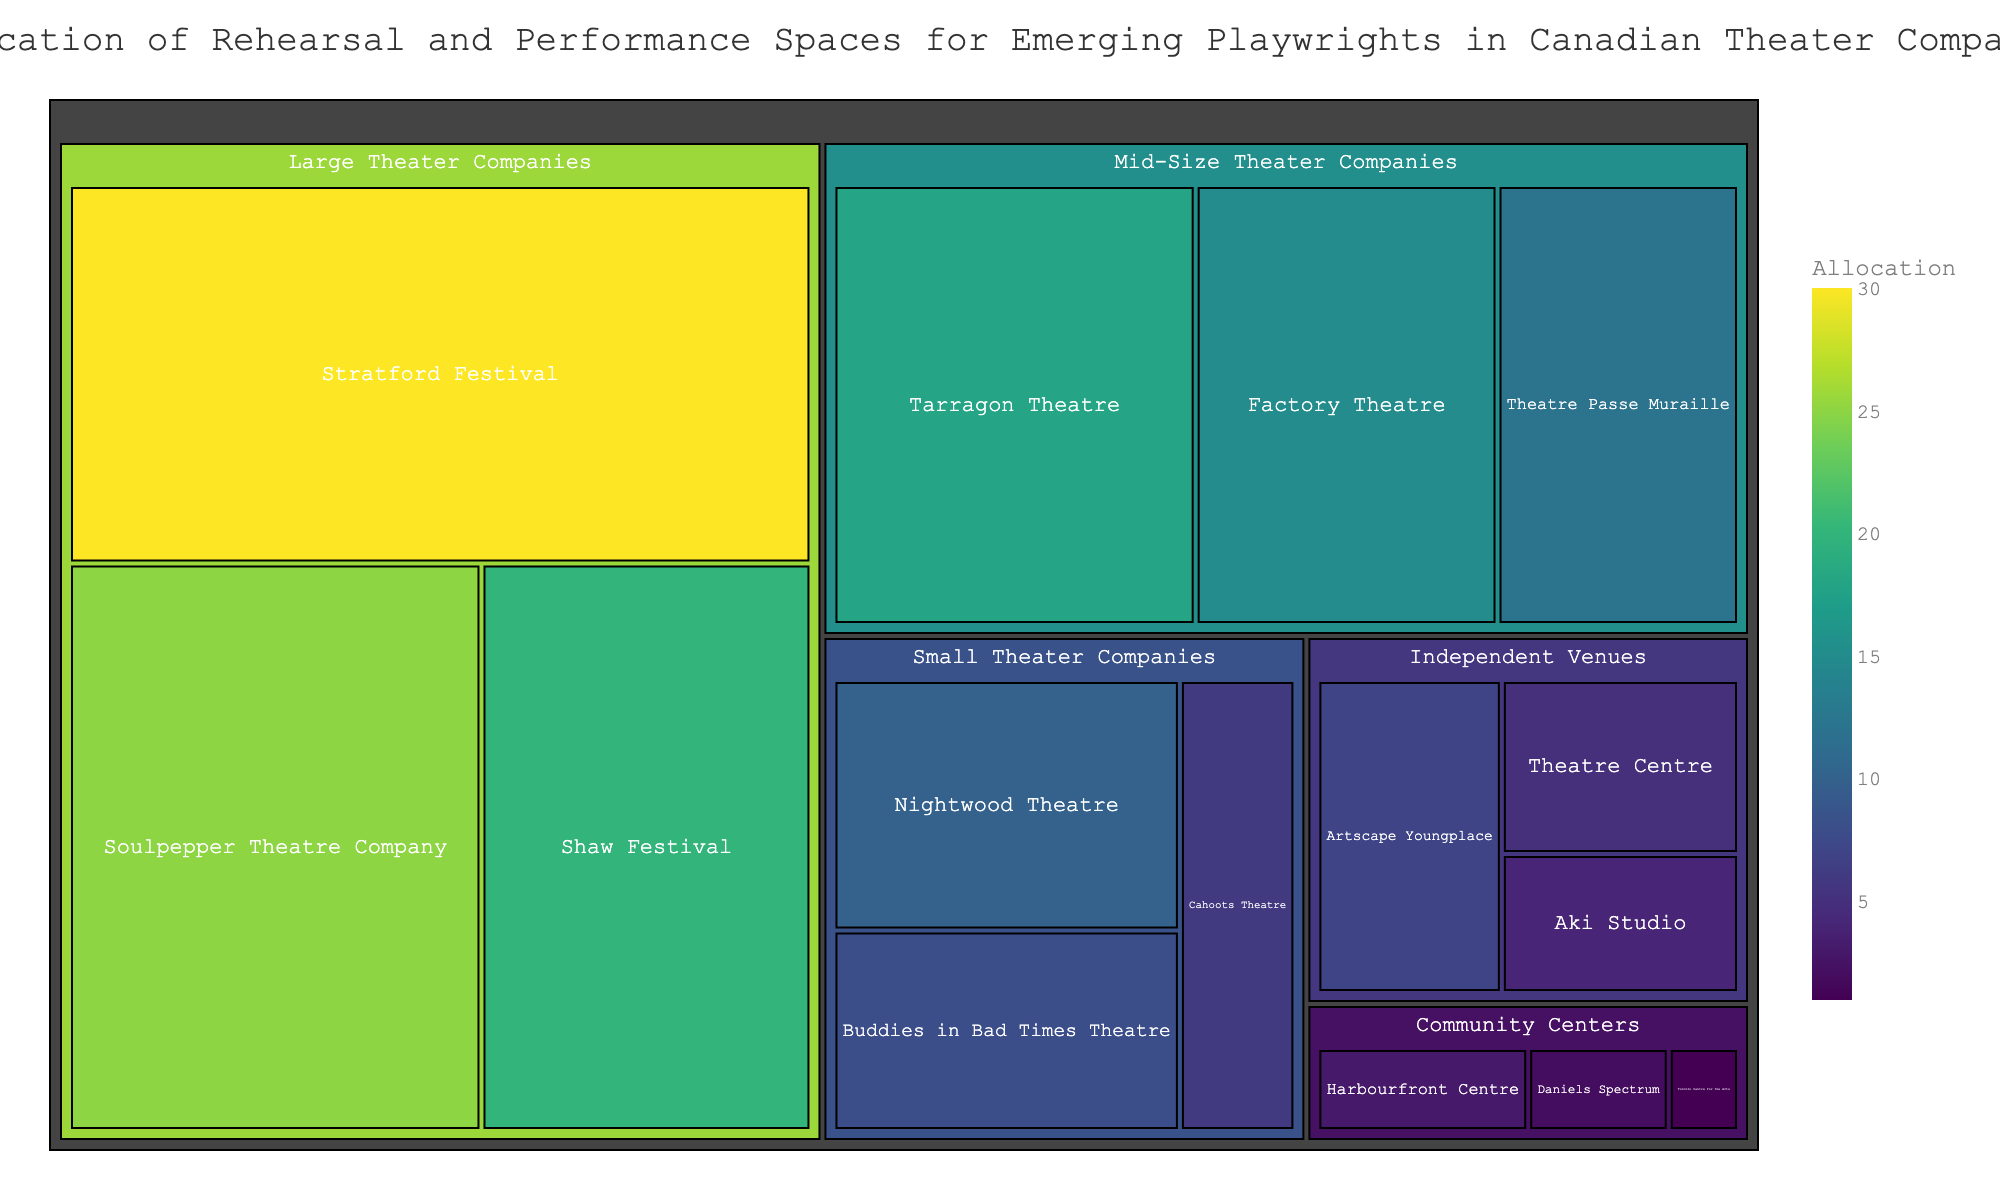what's the title of this treemap? The title is usually written at the top of the treemap, indicating what the chart represents. In this case, it is 'Allocation of Rehearsal and Performance Spaces for Emerging Playwrights in Canadian Theater Companies'.
Answer: Allocation of Rehearsal and Performance Spaces for Emerging Playwrights in Canadian Theater Companies which subcategory within the 'Large Theater Companies' has the highest value? By looking at the 'Large Theater Companies' section in the treemap, we can see that the Stratford Festival has the highest allocation value of 30.
Answer: Stratford Festival what's the combined allocation value for all 'Community Centers'? Add up the values for each subcategory under 'Community Centers': Harbourfront Centre (3), Daniels Spectrum (2), and Toronto Centre for the Arts (1). 3 + 2 + 1 = 6.
Answer: 6 which category has the lowest total allocation value? By summing up the values for each subcategory in all categories, 'Community Centers' has the lowest total allocation value of 6.
Answer: Community Centers how does the value for 'Tarragon Theatre' compare to 'Buddies in Bad Times Theatre'? Tarragon Theatre (18) has a higher allocation value compared to Buddies in Bad Times Theatre (8).
Answer: Tarragon Theatre is higher in the 'Independent Venues' category, which subcategory has the lowest allocation? Under the 'Independent Venues' category, Aki Studio has the lowest allocation value of 4.
Answer: Aki Studio what's the average allocation value for 'Mid-Size Theater Companies'? Add up the values for each subcategory under 'Mid-Size Theater Companies': Factory Theatre (15), Tarragon Theatre (18), and Theatre Passe Muraille (12). The total is 15 + 18 + 12 = 45. The average is 45 / 3 = 15.
Answer: 15 how many subcategories are there in the 'Small Theater Companies' category? Counting the number of subcategories under 'Small Theater Companies', we see there are three subcategories: Buddies in Bad Times Theatre, Nightwood Theatre, and Cahoots Theatre.
Answer: 3 compare the total allocation values of 'Large Theater Companies' and 'Mid-Size Theater Companies'. Which is greater? Sum the values for 'Large Theater Companies': Soulpepper Theatre Company (25), Stratford Festival (30), Shaw Festival (20), for a total of 75. Sum the values for 'Mid-Size Theater Companies': Factory Theatre (15), Tarragon Theatre (18), Theatre Passe Muraille (12), for a total of 45. 75 is greater than 45.
Answer: Large Theater Companies 